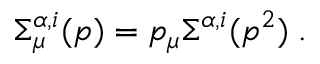<formula> <loc_0><loc_0><loc_500><loc_500>\Sigma _ { \mu } ^ { \alpha , i } ( p ) = p _ { \mu } \Sigma ^ { \alpha , i } ( p ^ { 2 } ) \, .</formula> 